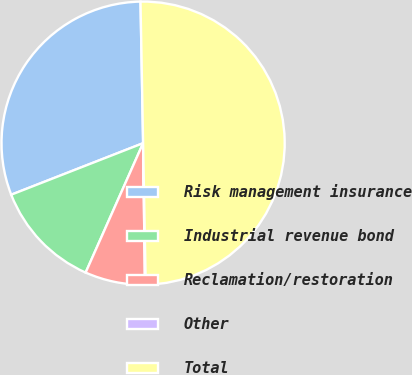Convert chart to OTSL. <chart><loc_0><loc_0><loc_500><loc_500><pie_chart><fcel>Risk management insurance<fcel>Industrial revenue bond<fcel>Reclamation/restoration<fcel>Other<fcel>Total<nl><fcel>30.64%<fcel>12.42%<fcel>6.86%<fcel>0.09%<fcel>50.0%<nl></chart> 